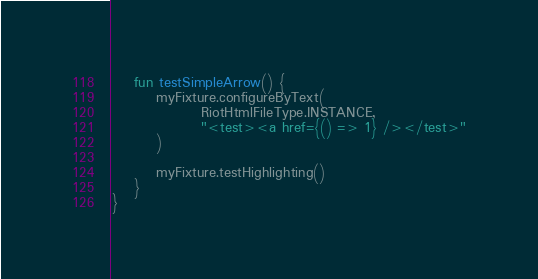<code> <loc_0><loc_0><loc_500><loc_500><_Kotlin_>    fun testSimpleArrow() {
        myFixture.configureByText(
                RiotHtmlFileType.INSTANCE,
                "<test><a href={() => 1} /></test>"
        )

        myFixture.testHighlighting()
    }
}
</code> 